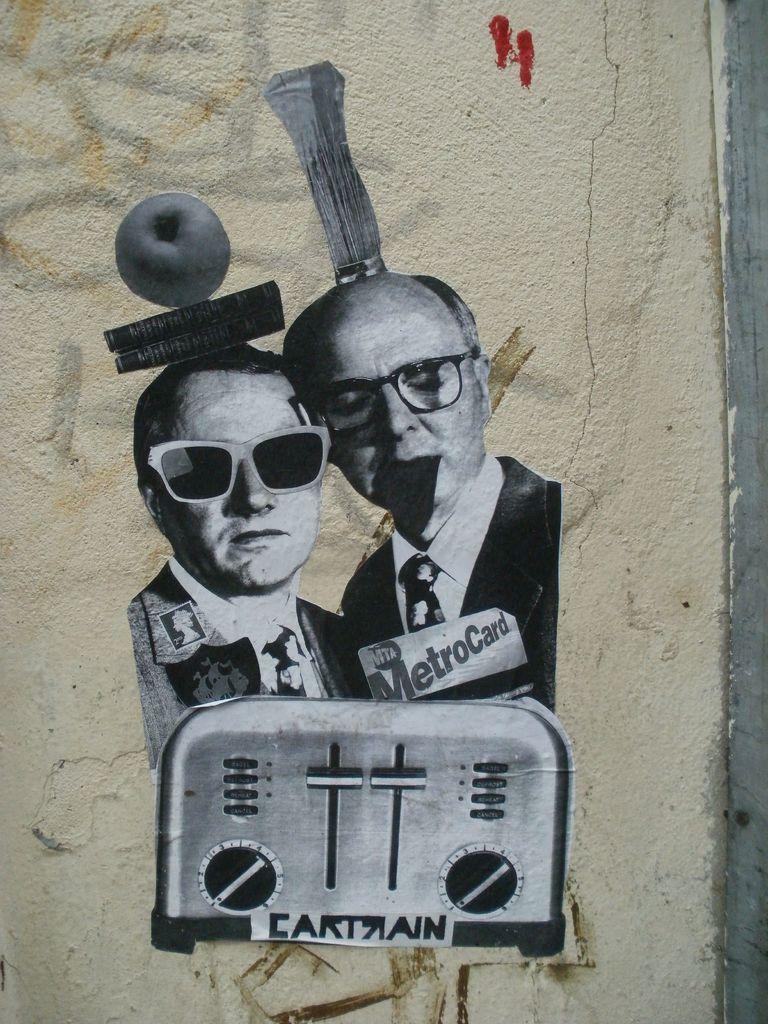Could you give a brief overview of what you see in this image? In the center of this picture we can see the pictures of two persons and we can see the text and the picture of an object and the picture of an apple. In the background we can see the wall. 